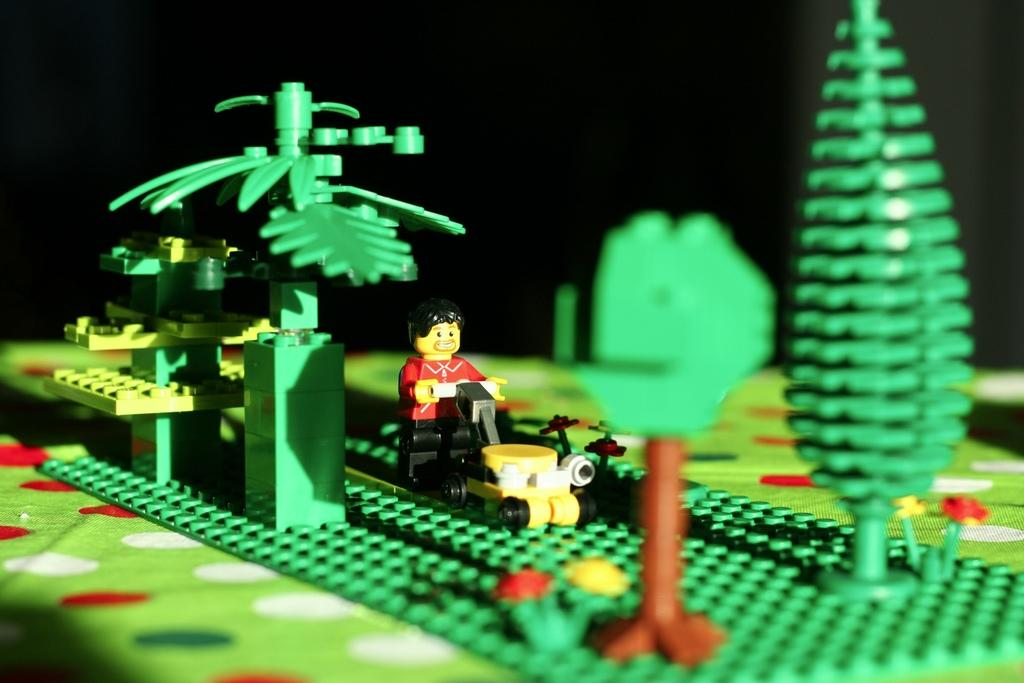What type of objects are in the image? There are building blocks and a toy of a person in the image. Can you describe the background of the image? The background of the image is dark. What day of the week is depicted in the image? There is no reference to a specific day of the week in the image. How does the toy person compare to a real person in the image? The image does not include a real person for comparison. 